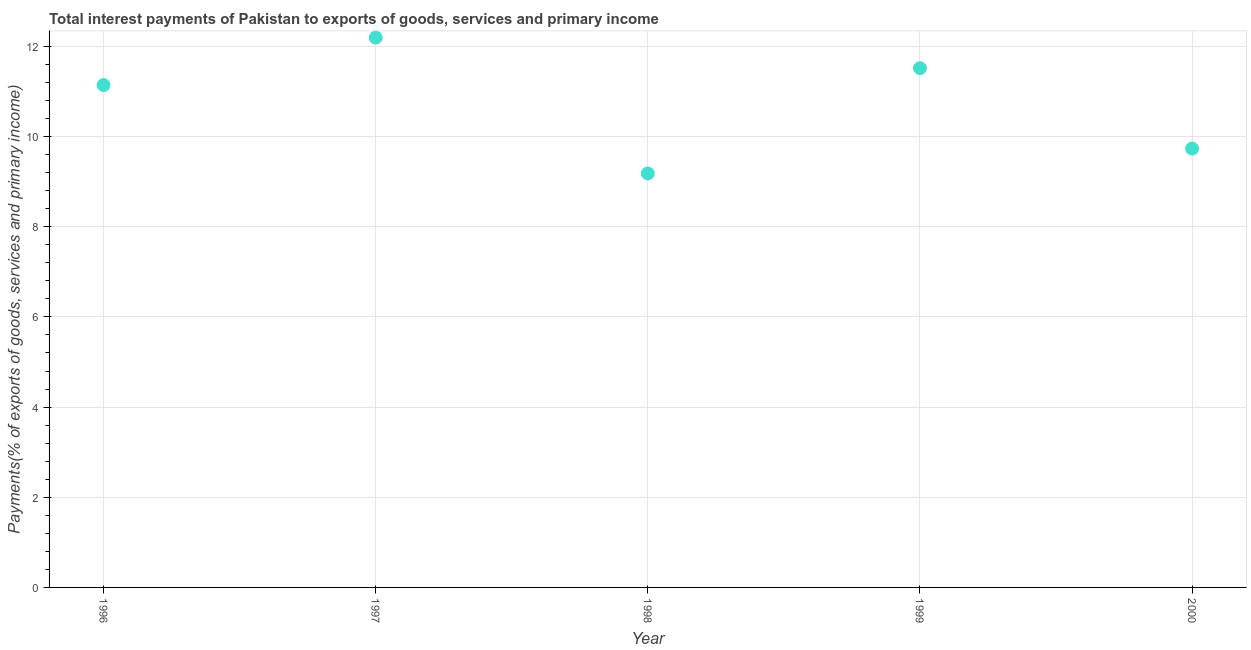What is the total interest payments on external debt in 1996?
Your response must be concise. 11.14. Across all years, what is the maximum total interest payments on external debt?
Keep it short and to the point. 12.2. Across all years, what is the minimum total interest payments on external debt?
Offer a terse response. 9.18. In which year was the total interest payments on external debt maximum?
Keep it short and to the point. 1997. What is the sum of the total interest payments on external debt?
Make the answer very short. 53.77. What is the difference between the total interest payments on external debt in 1997 and 1998?
Offer a very short reply. 3.01. What is the average total interest payments on external debt per year?
Make the answer very short. 10.75. What is the median total interest payments on external debt?
Your response must be concise. 11.14. In how many years, is the total interest payments on external debt greater than 8 %?
Offer a very short reply. 5. What is the ratio of the total interest payments on external debt in 1997 to that in 1998?
Your response must be concise. 1.33. What is the difference between the highest and the second highest total interest payments on external debt?
Provide a short and direct response. 0.68. What is the difference between the highest and the lowest total interest payments on external debt?
Provide a succinct answer. 3.01. Does the total interest payments on external debt monotonically increase over the years?
Give a very brief answer. No. How many dotlines are there?
Keep it short and to the point. 1. How many years are there in the graph?
Make the answer very short. 5. What is the difference between two consecutive major ticks on the Y-axis?
Offer a very short reply. 2. Are the values on the major ticks of Y-axis written in scientific E-notation?
Ensure brevity in your answer.  No. Does the graph contain any zero values?
Keep it short and to the point. No. What is the title of the graph?
Offer a terse response. Total interest payments of Pakistan to exports of goods, services and primary income. What is the label or title of the Y-axis?
Provide a succinct answer. Payments(% of exports of goods, services and primary income). What is the Payments(% of exports of goods, services and primary income) in 1996?
Provide a succinct answer. 11.14. What is the Payments(% of exports of goods, services and primary income) in 1997?
Your answer should be very brief. 12.2. What is the Payments(% of exports of goods, services and primary income) in 1998?
Your answer should be very brief. 9.18. What is the Payments(% of exports of goods, services and primary income) in 1999?
Your response must be concise. 11.52. What is the Payments(% of exports of goods, services and primary income) in 2000?
Give a very brief answer. 9.73. What is the difference between the Payments(% of exports of goods, services and primary income) in 1996 and 1997?
Ensure brevity in your answer.  -1.05. What is the difference between the Payments(% of exports of goods, services and primary income) in 1996 and 1998?
Your answer should be very brief. 1.96. What is the difference between the Payments(% of exports of goods, services and primary income) in 1996 and 1999?
Make the answer very short. -0.37. What is the difference between the Payments(% of exports of goods, services and primary income) in 1996 and 2000?
Ensure brevity in your answer.  1.41. What is the difference between the Payments(% of exports of goods, services and primary income) in 1997 and 1998?
Offer a terse response. 3.01. What is the difference between the Payments(% of exports of goods, services and primary income) in 1997 and 1999?
Offer a very short reply. 0.68. What is the difference between the Payments(% of exports of goods, services and primary income) in 1997 and 2000?
Make the answer very short. 2.46. What is the difference between the Payments(% of exports of goods, services and primary income) in 1998 and 1999?
Keep it short and to the point. -2.34. What is the difference between the Payments(% of exports of goods, services and primary income) in 1998 and 2000?
Offer a very short reply. -0.55. What is the difference between the Payments(% of exports of goods, services and primary income) in 1999 and 2000?
Keep it short and to the point. 1.78. What is the ratio of the Payments(% of exports of goods, services and primary income) in 1996 to that in 1997?
Provide a succinct answer. 0.91. What is the ratio of the Payments(% of exports of goods, services and primary income) in 1996 to that in 1998?
Your answer should be very brief. 1.21. What is the ratio of the Payments(% of exports of goods, services and primary income) in 1996 to that in 2000?
Offer a very short reply. 1.15. What is the ratio of the Payments(% of exports of goods, services and primary income) in 1997 to that in 1998?
Ensure brevity in your answer.  1.33. What is the ratio of the Payments(% of exports of goods, services and primary income) in 1997 to that in 1999?
Make the answer very short. 1.06. What is the ratio of the Payments(% of exports of goods, services and primary income) in 1997 to that in 2000?
Provide a short and direct response. 1.25. What is the ratio of the Payments(% of exports of goods, services and primary income) in 1998 to that in 1999?
Offer a very short reply. 0.8. What is the ratio of the Payments(% of exports of goods, services and primary income) in 1998 to that in 2000?
Your answer should be very brief. 0.94. What is the ratio of the Payments(% of exports of goods, services and primary income) in 1999 to that in 2000?
Offer a terse response. 1.18. 